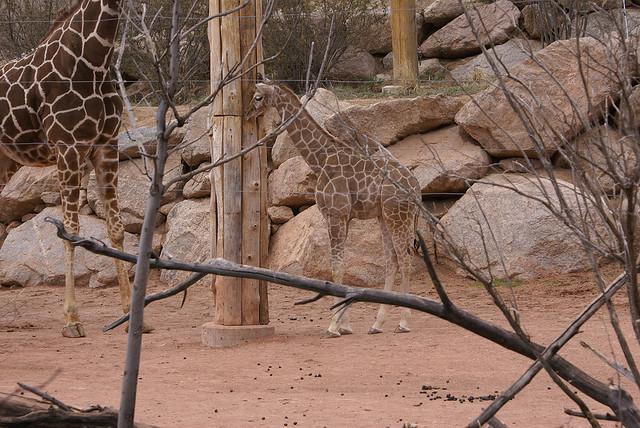How many giraffes?
Concise answer only. 2. What color are the stripes?
Keep it brief. White. Are any of these giraffes fully grown?
Keep it brief. Yes. How many animals are there?
Concise answer only. 2. What is behind the tree?
Short answer required. Giraffe. Are the giraffes the same size?
Write a very short answer. No. How many giraffes are in the picture?
Be succinct. 2. Does this animal has a horn?
Give a very brief answer. No. How many zebras are there?
Answer briefly. 0. How many legs does the giraffe have?
Keep it brief. 4. What's in front of the giraffes?
Write a very short answer. Pole. Where are the rocks?
Quick response, please. Behind giraffes. Are the giraffes drinking water?
Give a very brief answer. No. Is this a baby giraffe?
Write a very short answer. Yes. What kind of animal are these?
Keep it brief. Giraffes. Is the tree bare?
Short answer required. Yes. 